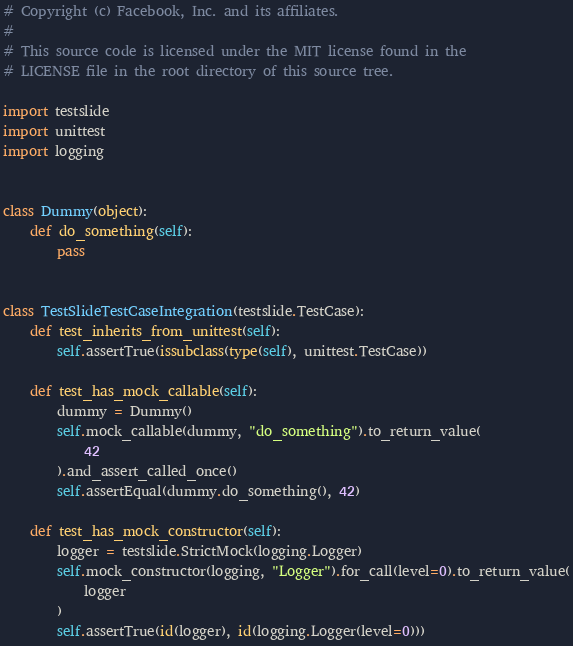Convert code to text. <code><loc_0><loc_0><loc_500><loc_500><_Python_># Copyright (c) Facebook, Inc. and its affiliates.
#
# This source code is licensed under the MIT license found in the
# LICENSE file in the root directory of this source tree.

import testslide
import unittest
import logging


class Dummy(object):
    def do_something(self):
        pass


class TestSlideTestCaseIntegration(testslide.TestCase):
    def test_inherits_from_unittest(self):
        self.assertTrue(issubclass(type(self), unittest.TestCase))

    def test_has_mock_callable(self):
        dummy = Dummy()
        self.mock_callable(dummy, "do_something").to_return_value(
            42
        ).and_assert_called_once()
        self.assertEqual(dummy.do_something(), 42)

    def test_has_mock_constructor(self):
        logger = testslide.StrictMock(logging.Logger)
        self.mock_constructor(logging, "Logger").for_call(level=0).to_return_value(
            logger
        )
        self.assertTrue(id(logger), id(logging.Logger(level=0)))
</code> 